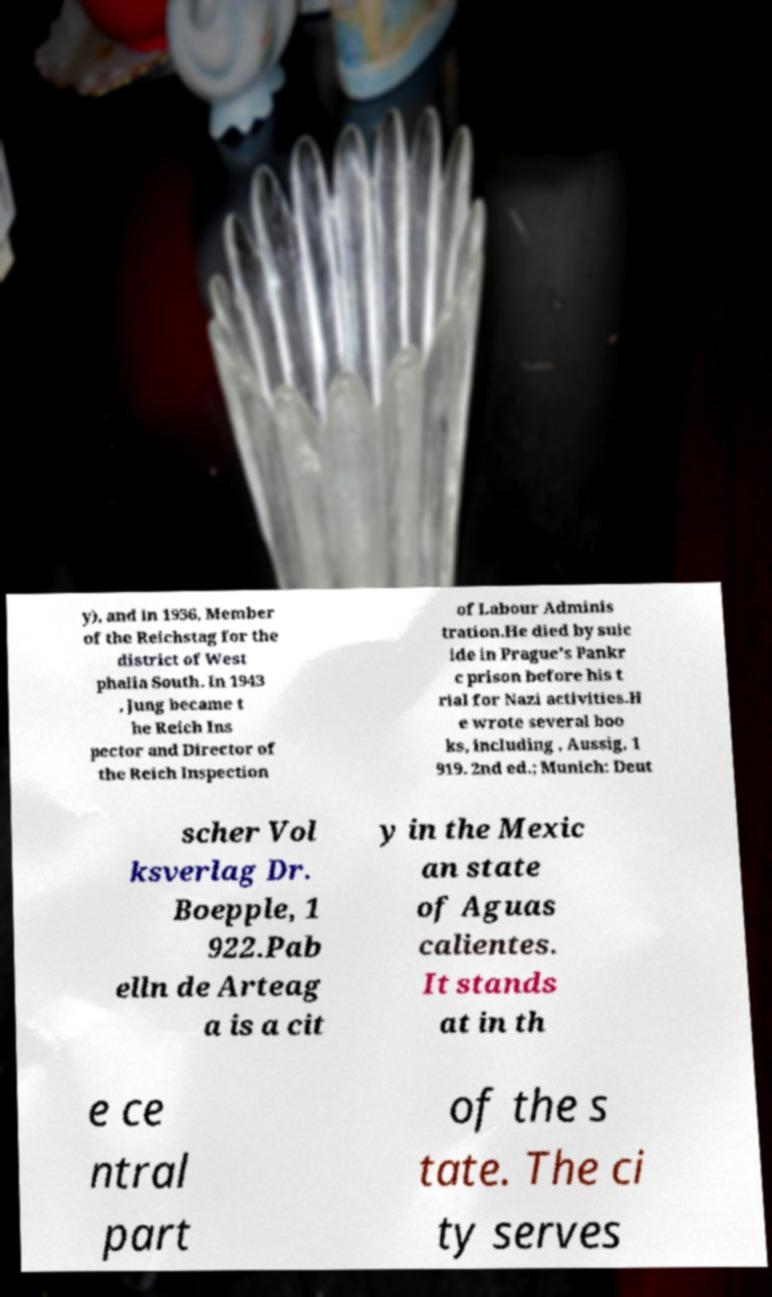Please identify and transcribe the text found in this image. y), and in 1936, Member of the Reichstag for the district of West phalia South. In 1943 , Jung became t he Reich Ins pector and Director of the Reich Inspection of Labour Adminis tration.He died by suic ide in Prague's Pankr c prison before his t rial for Nazi activities.H e wrote several boo ks, including , Aussig, 1 919. 2nd ed.; Munich: Deut scher Vol ksverlag Dr. Boepple, 1 922.Pab elln de Arteag a is a cit y in the Mexic an state of Aguas calientes. It stands at in th e ce ntral part of the s tate. The ci ty serves 